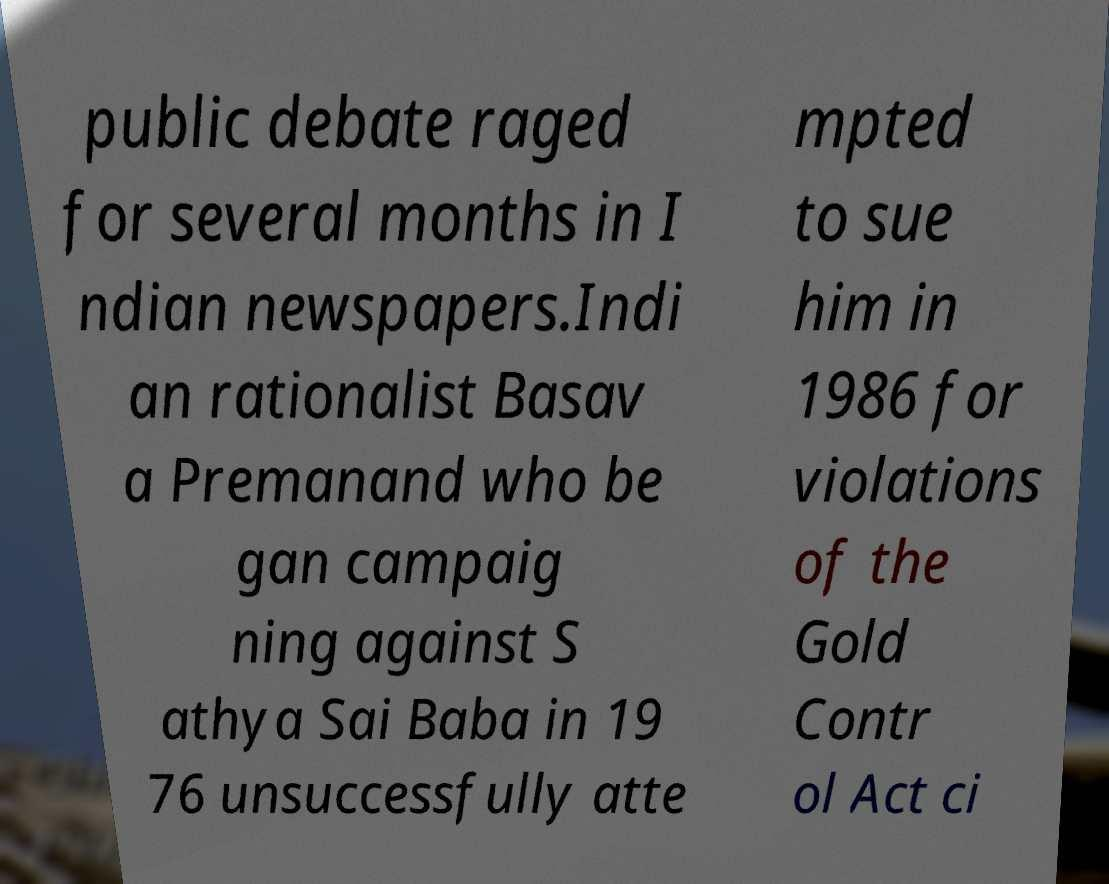I need the written content from this picture converted into text. Can you do that? public debate raged for several months in I ndian newspapers.Indi an rationalist Basav a Premanand who be gan campaig ning against S athya Sai Baba in 19 76 unsuccessfully atte mpted to sue him in 1986 for violations of the Gold Contr ol Act ci 